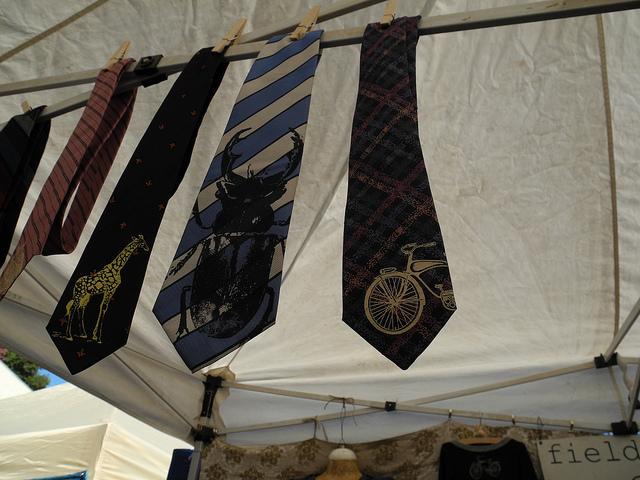What vehicle is on one of the ties?
Keep it brief. Bicycle. What is the material behind the neckties?
Concise answer only. Cotton. What pattern does the 4 tie from the right have?
Short answer required. Stripes. Are surfboards being stored here?
Write a very short answer. No. What piece of neckwear is shown here?
Give a very brief answer. Tie. How many ties are there?
Short answer required. 5. What animal is on the tie?
Write a very short answer. Giraffe. 